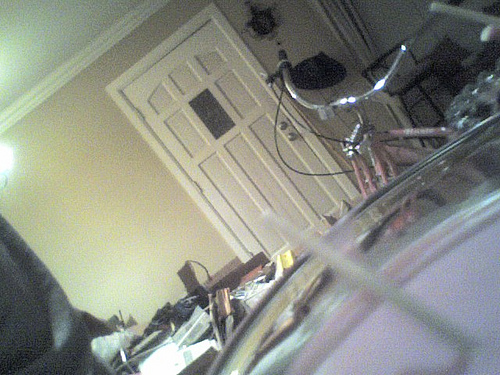<image>
Is there a door under the cycle? No. The door is not positioned under the cycle. The vertical relationship between these objects is different. 